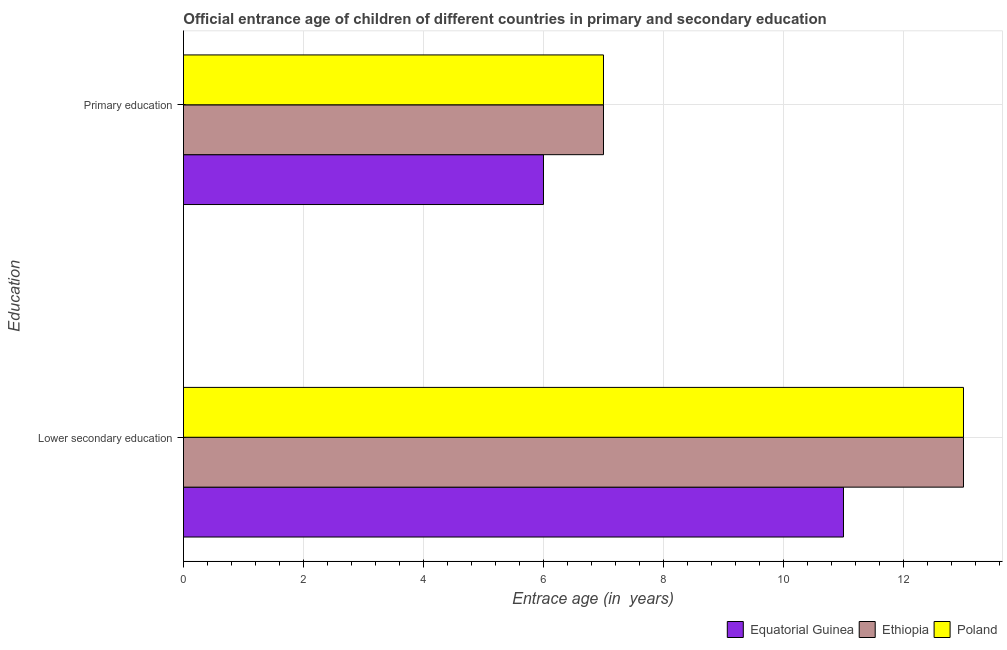How many different coloured bars are there?
Offer a very short reply. 3. What is the label of the 2nd group of bars from the top?
Give a very brief answer. Lower secondary education. What is the entrance age of chiildren in primary education in Poland?
Your answer should be compact. 7. Across all countries, what is the maximum entrance age of chiildren in primary education?
Offer a very short reply. 7. Across all countries, what is the minimum entrance age of chiildren in primary education?
Your answer should be very brief. 6. In which country was the entrance age of chiildren in primary education maximum?
Keep it short and to the point. Ethiopia. In which country was the entrance age of chiildren in primary education minimum?
Keep it short and to the point. Equatorial Guinea. What is the total entrance age of children in lower secondary education in the graph?
Your answer should be compact. 37. What is the difference between the entrance age of chiildren in primary education in Equatorial Guinea and that in Ethiopia?
Make the answer very short. -1. What is the difference between the entrance age of chiildren in primary education in Poland and the entrance age of children in lower secondary education in Equatorial Guinea?
Give a very brief answer. -4. What is the average entrance age of children in lower secondary education per country?
Give a very brief answer. 12.33. What is the difference between the entrance age of chiildren in primary education and entrance age of children in lower secondary education in Poland?
Keep it short and to the point. -6. In how many countries, is the entrance age of chiildren in primary education greater than 10.8 years?
Your answer should be compact. 0. What is the ratio of the entrance age of children in lower secondary education in Ethiopia to that in Equatorial Guinea?
Your answer should be very brief. 1.18. Is the entrance age of children in lower secondary education in Ethiopia less than that in Equatorial Guinea?
Provide a succinct answer. No. What does the 3rd bar from the top in Lower secondary education represents?
Provide a short and direct response. Equatorial Guinea. What does the 2nd bar from the bottom in Lower secondary education represents?
Your response must be concise. Ethiopia. How many bars are there?
Offer a terse response. 6. Are all the bars in the graph horizontal?
Offer a terse response. Yes. How many countries are there in the graph?
Your answer should be compact. 3. Are the values on the major ticks of X-axis written in scientific E-notation?
Provide a short and direct response. No. Does the graph contain any zero values?
Ensure brevity in your answer.  No. Does the graph contain grids?
Provide a short and direct response. Yes. How many legend labels are there?
Give a very brief answer. 3. What is the title of the graph?
Your answer should be very brief. Official entrance age of children of different countries in primary and secondary education. Does "Andorra" appear as one of the legend labels in the graph?
Offer a very short reply. No. What is the label or title of the X-axis?
Keep it short and to the point. Entrace age (in  years). What is the label or title of the Y-axis?
Offer a very short reply. Education. What is the Entrace age (in  years) of Poland in Lower secondary education?
Your answer should be compact. 13. What is the Entrace age (in  years) in Equatorial Guinea in Primary education?
Your response must be concise. 6. Across all Education, what is the maximum Entrace age (in  years) in Equatorial Guinea?
Provide a succinct answer. 11. Across all Education, what is the maximum Entrace age (in  years) of Ethiopia?
Provide a short and direct response. 13. Across all Education, what is the maximum Entrace age (in  years) of Poland?
Your answer should be very brief. 13. Across all Education, what is the minimum Entrace age (in  years) of Equatorial Guinea?
Offer a very short reply. 6. What is the total Entrace age (in  years) in Equatorial Guinea in the graph?
Give a very brief answer. 17. What is the total Entrace age (in  years) in Ethiopia in the graph?
Provide a succinct answer. 20. What is the difference between the Entrace age (in  years) in Equatorial Guinea in Lower secondary education and that in Primary education?
Make the answer very short. 5. What is the difference between the Entrace age (in  years) in Ethiopia in Lower secondary education and that in Primary education?
Give a very brief answer. 6. What is the difference between the Entrace age (in  years) of Poland in Lower secondary education and that in Primary education?
Your answer should be compact. 6. What is the difference between the Entrace age (in  years) in Equatorial Guinea in Lower secondary education and the Entrace age (in  years) in Ethiopia in Primary education?
Provide a short and direct response. 4. What is the difference between the Entrace age (in  years) of Ethiopia in Lower secondary education and the Entrace age (in  years) of Poland in Primary education?
Provide a short and direct response. 6. What is the average Entrace age (in  years) of Ethiopia per Education?
Make the answer very short. 10. What is the difference between the Entrace age (in  years) of Equatorial Guinea and Entrace age (in  years) of Ethiopia in Lower secondary education?
Your answer should be very brief. -2. What is the difference between the Entrace age (in  years) of Ethiopia and Entrace age (in  years) of Poland in Lower secondary education?
Provide a succinct answer. 0. What is the difference between the Entrace age (in  years) in Equatorial Guinea and Entrace age (in  years) in Poland in Primary education?
Provide a succinct answer. -1. What is the ratio of the Entrace age (in  years) of Equatorial Guinea in Lower secondary education to that in Primary education?
Ensure brevity in your answer.  1.83. What is the ratio of the Entrace age (in  years) in Ethiopia in Lower secondary education to that in Primary education?
Make the answer very short. 1.86. What is the ratio of the Entrace age (in  years) of Poland in Lower secondary education to that in Primary education?
Your answer should be very brief. 1.86. What is the difference between the highest and the second highest Entrace age (in  years) of Ethiopia?
Your answer should be very brief. 6. What is the difference between the highest and the lowest Entrace age (in  years) of Equatorial Guinea?
Provide a short and direct response. 5. What is the difference between the highest and the lowest Entrace age (in  years) of Ethiopia?
Keep it short and to the point. 6. 